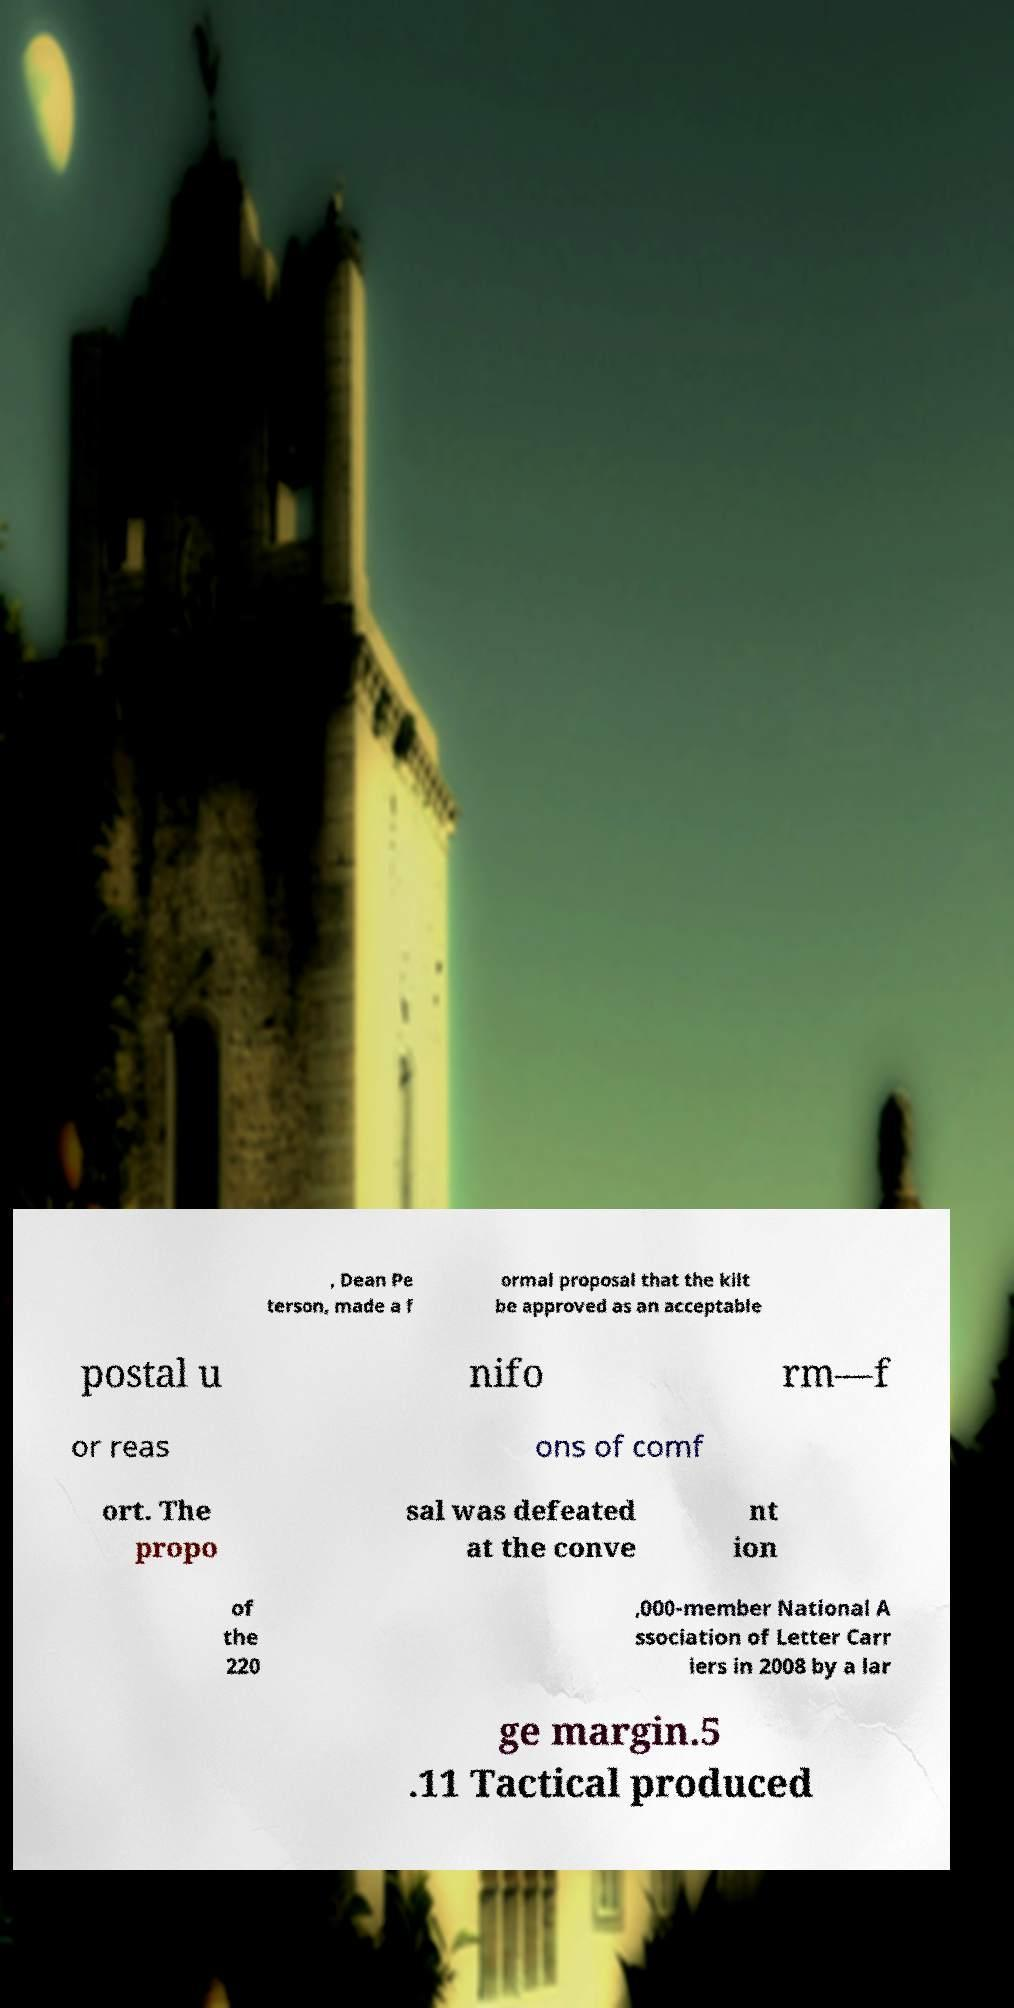Can you read and provide the text displayed in the image?This photo seems to have some interesting text. Can you extract and type it out for me? , Dean Pe terson, made a f ormal proposal that the kilt be approved as an acceptable postal u nifo rm—f or reas ons of comf ort. The propo sal was defeated at the conve nt ion of the 220 ,000-member National A ssociation of Letter Carr iers in 2008 by a lar ge margin.5 .11 Tactical produced 